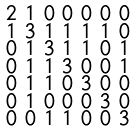<formula> <loc_0><loc_0><loc_500><loc_500>\begin{smallmatrix} 2 & 1 & 0 & 0 & 0 & 0 & 0 \\ 1 & 3 & 1 & 1 & 1 & 1 & 0 \\ 0 & 1 & 3 & 1 & 1 & 0 & 1 \\ 0 & 1 & 1 & 3 & 0 & 0 & 1 \\ 0 & 1 & 1 & 0 & 3 & 0 & 0 \\ 0 & 1 & 0 & 0 & 0 & 3 & 0 \\ 0 & 0 & 1 & 1 & 0 & 0 & 3 \end{smallmatrix}</formula> 